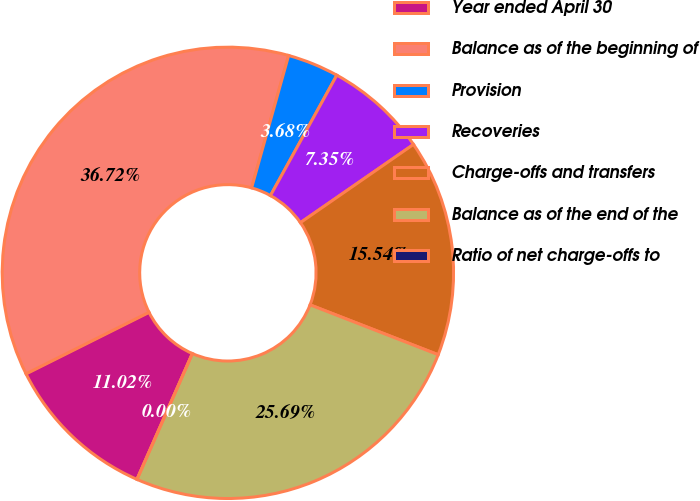Convert chart. <chart><loc_0><loc_0><loc_500><loc_500><pie_chart><fcel>Year ended April 30<fcel>Balance as of the beginning of<fcel>Provision<fcel>Recoveries<fcel>Charge-offs and transfers<fcel>Balance as of the end of the<fcel>Ratio of net charge-offs to<nl><fcel>11.02%<fcel>36.72%<fcel>3.68%<fcel>7.35%<fcel>15.54%<fcel>25.69%<fcel>0.0%<nl></chart> 